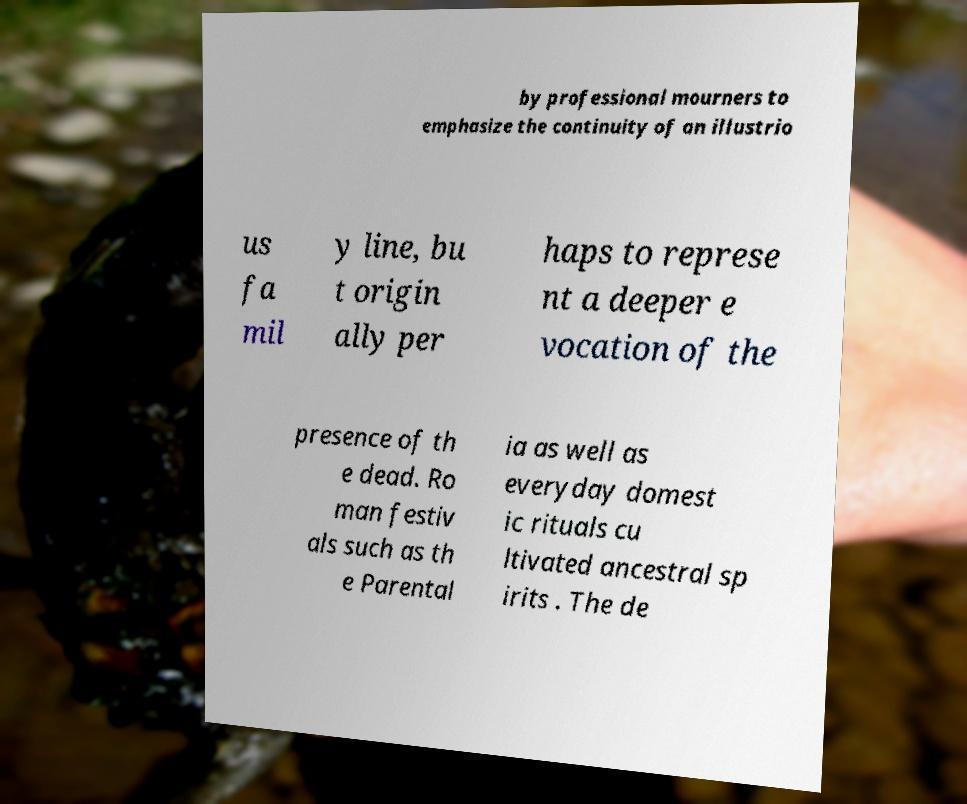Can you accurately transcribe the text from the provided image for me? by professional mourners to emphasize the continuity of an illustrio us fa mil y line, bu t origin ally per haps to represe nt a deeper e vocation of the presence of th e dead. Ro man festiv als such as th e Parental ia as well as everyday domest ic rituals cu ltivated ancestral sp irits . The de 